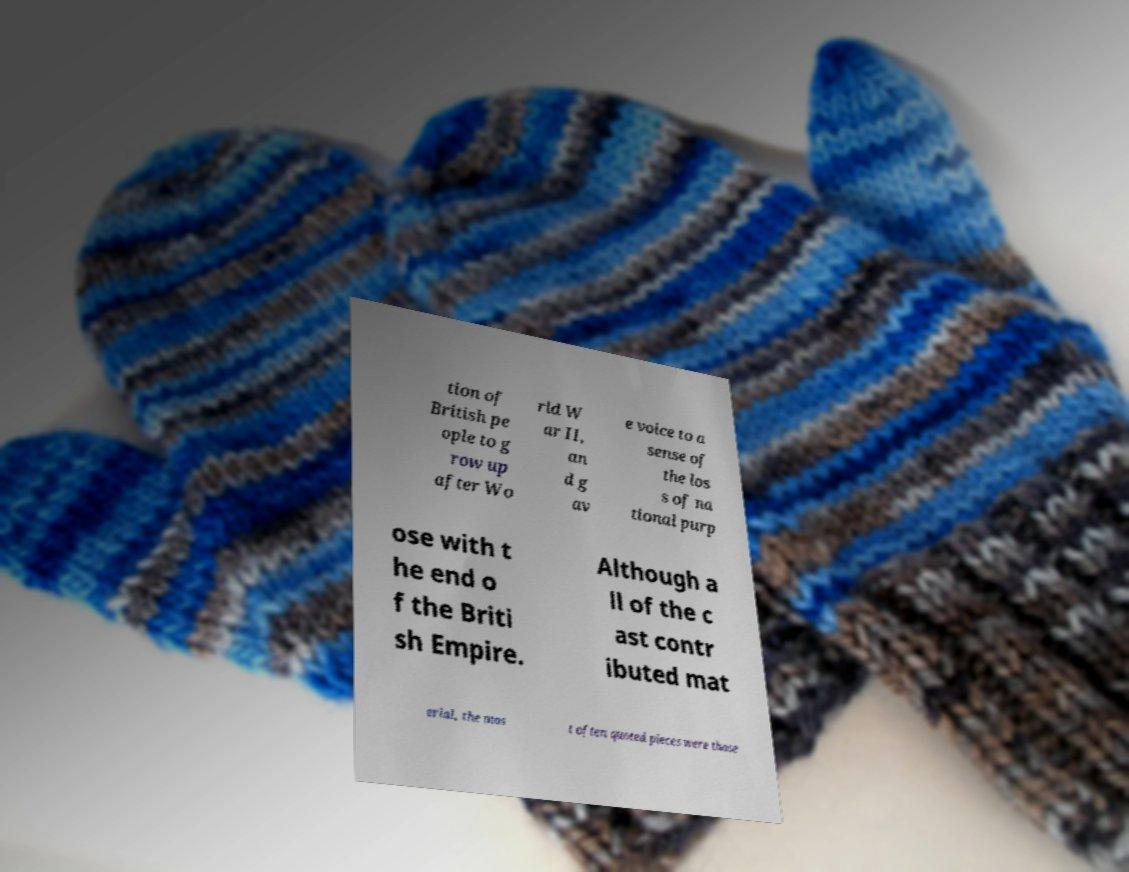For documentation purposes, I need the text within this image transcribed. Could you provide that? tion of British pe ople to g row up after Wo rld W ar II, an d g av e voice to a sense of the los s of na tional purp ose with t he end o f the Briti sh Empire. Although a ll of the c ast contr ibuted mat erial, the mos t often quoted pieces were those 